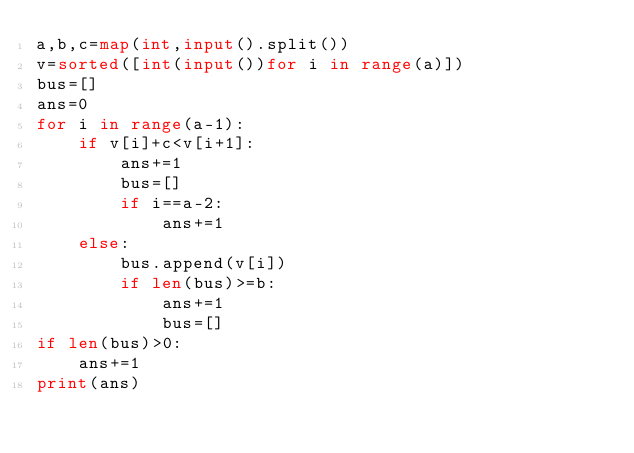<code> <loc_0><loc_0><loc_500><loc_500><_Python_>a,b,c=map(int,input().split())
v=sorted([int(input())for i in range(a)])
bus=[]
ans=0
for i in range(a-1):
    if v[i]+c<v[i+1]:
        ans+=1
        bus=[]
        if i==a-2:
            ans+=1
    else:
        bus.append(v[i])
        if len(bus)>=b:
            ans+=1
            bus=[]
if len(bus)>0:
    ans+=1
print(ans)</code> 